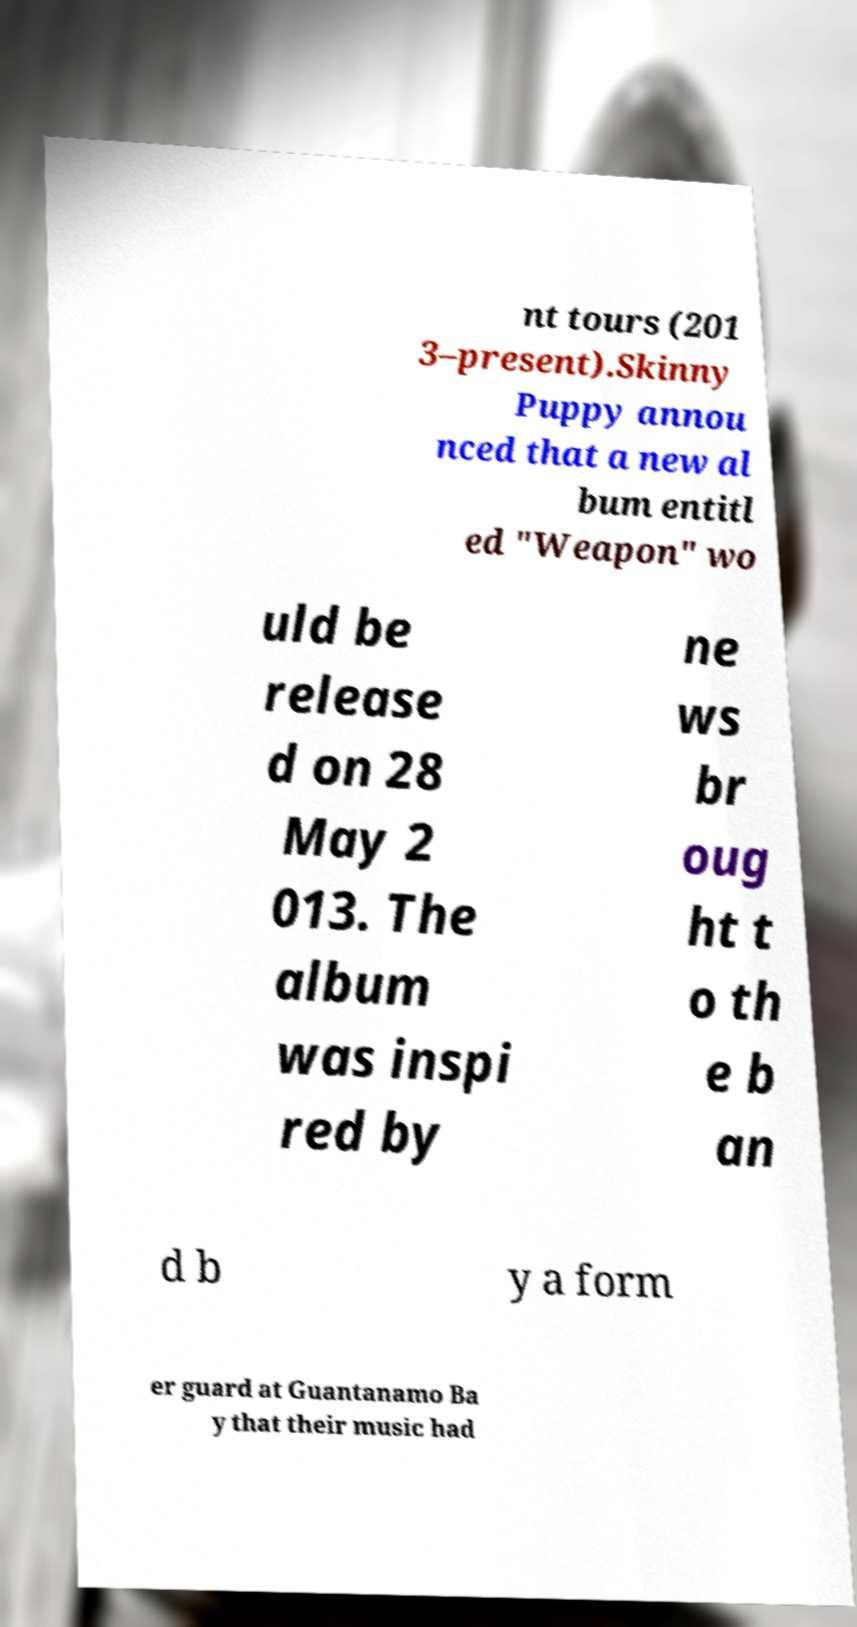I need the written content from this picture converted into text. Can you do that? nt tours (201 3–present).Skinny Puppy annou nced that a new al bum entitl ed "Weapon" wo uld be release d on 28 May 2 013. The album was inspi red by ne ws br oug ht t o th e b an d b y a form er guard at Guantanamo Ba y that their music had 